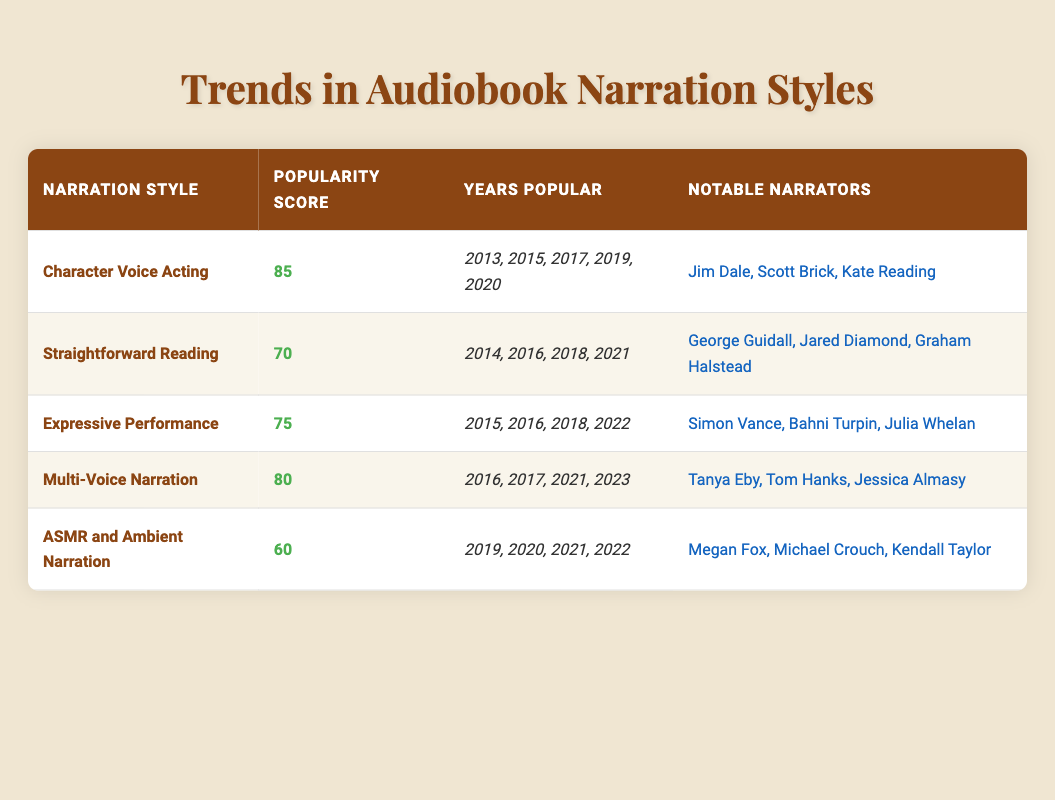What is the highest popularity score among the narration styles? By examining the popularity scores for each style, we find the scores: Character Voice Acting (85), Straightforward Reading (70), Expressive Performance (75), Multi-Voice Narration (80), and ASMR and Ambient Narration (60). The highest score is 85.
Answer: 85 Which narration styles are noted for the year 2017? The table indicates the years popular for each style. Character Voice Acting, Expressive Performance, and Multi-Voice Narration all include the year 2017 in their list of popular years.
Answer: Character Voice Acting, Expressive Performance, Multi-Voice Narration True or False: ASMR and Ambient Narration is the least popular style based on the popularity score. The popularity score for ASMR and Ambient Narration is 60, which is the lowest score compared to others: Character Voice Acting (85), Straightforward Reading (70), Expressive Performance (75), and Multi-Voice Narration (80). This confirms that the statement is true.
Answer: True What is the average popularity score of the styles that were popular in 2021? The styles popular in 2021 are Straightforward Reading (70), Multi-Voice Narration (80), and ASMR and Ambient Narration (60). To calculate the average: (70 + 80 + 60) / 3 = 210 / 3 = 70.
Answer: 70 How many notable narrators are associated with Expressive Performance? According to the table, the notable narrators for Expressive Performance are Simon Vance, Bahni Turpin, and Julia Whelan, totaling three narrators.
Answer: 3 Is it true that all styles listed have been popular in three or more different years? Checking each style, Character Voice Acting (5 years), Straightforward Reading (4 years), Expressive Performance (4 years), Multi-Voice Narration (4 years), and ASMR and Ambient Narration (4 years) confirm that each style has been popular in at least three years. Therefore, the statement is true.
Answer: True 